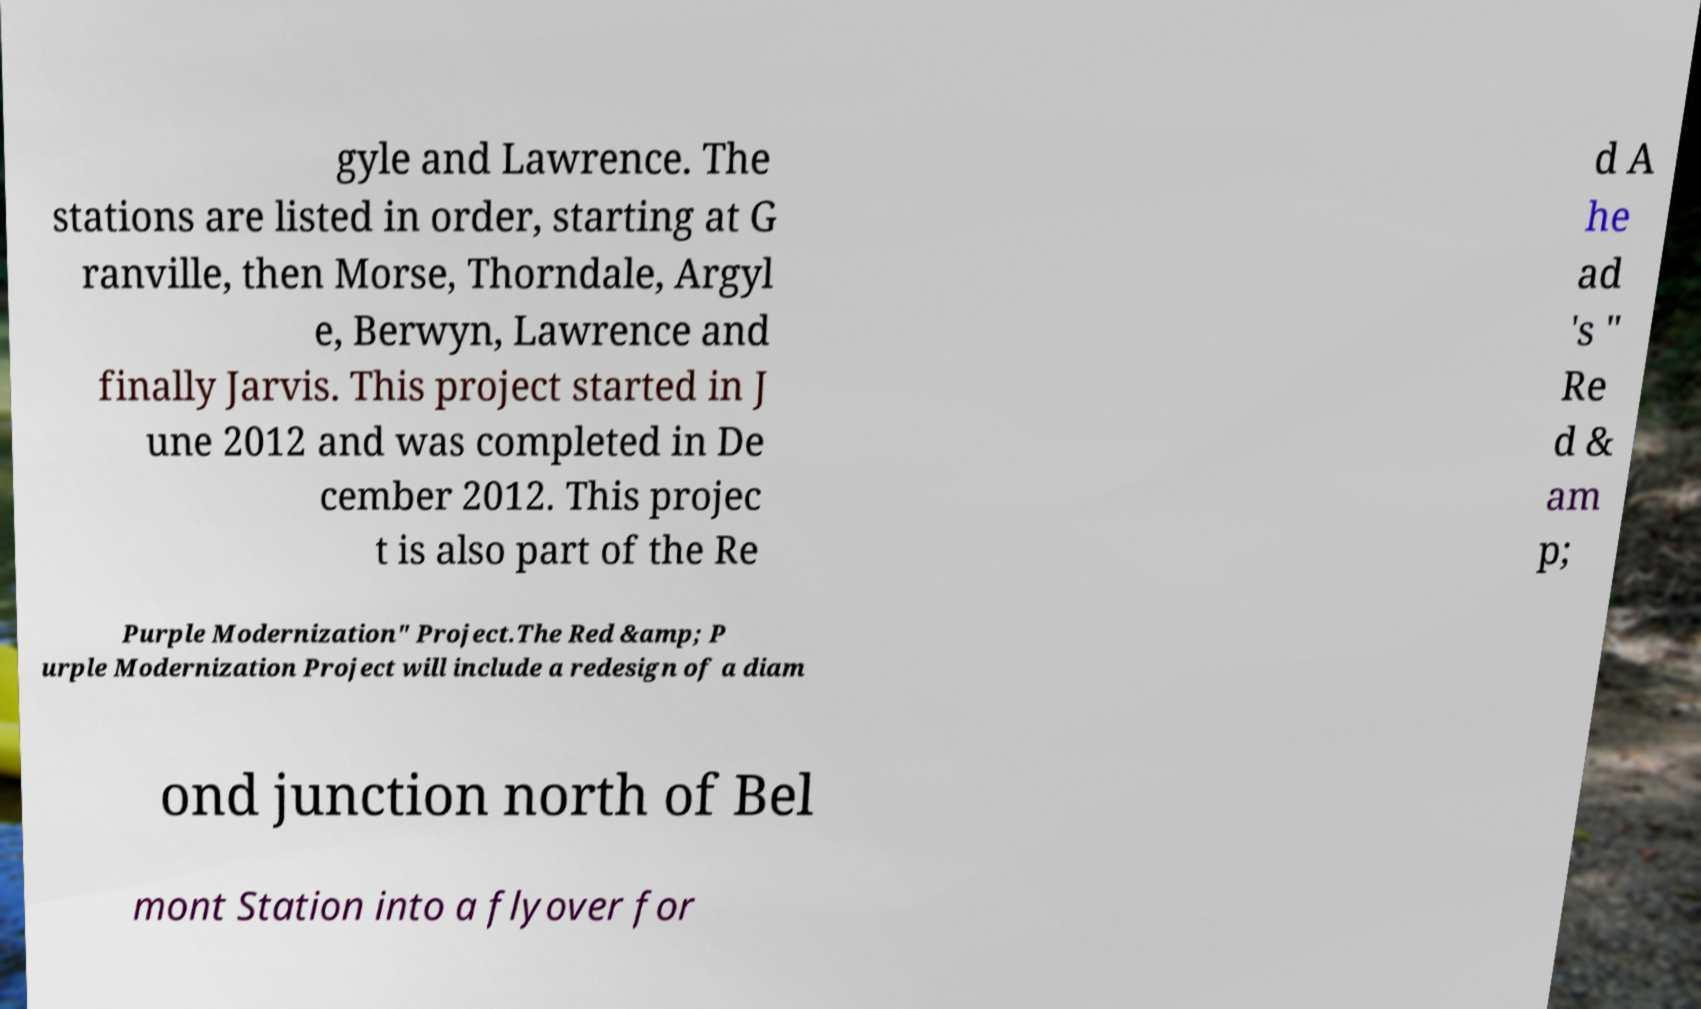Can you read and provide the text displayed in the image?This photo seems to have some interesting text. Can you extract and type it out for me? gyle and Lawrence. The stations are listed in order, starting at G ranville, then Morse, Thorndale, Argyl e, Berwyn, Lawrence and finally Jarvis. This project started in J une 2012 and was completed in De cember 2012. This projec t is also part of the Re d A he ad 's " Re d & am p; Purple Modernization" Project.The Red &amp; P urple Modernization Project will include a redesign of a diam ond junction north of Bel mont Station into a flyover for 